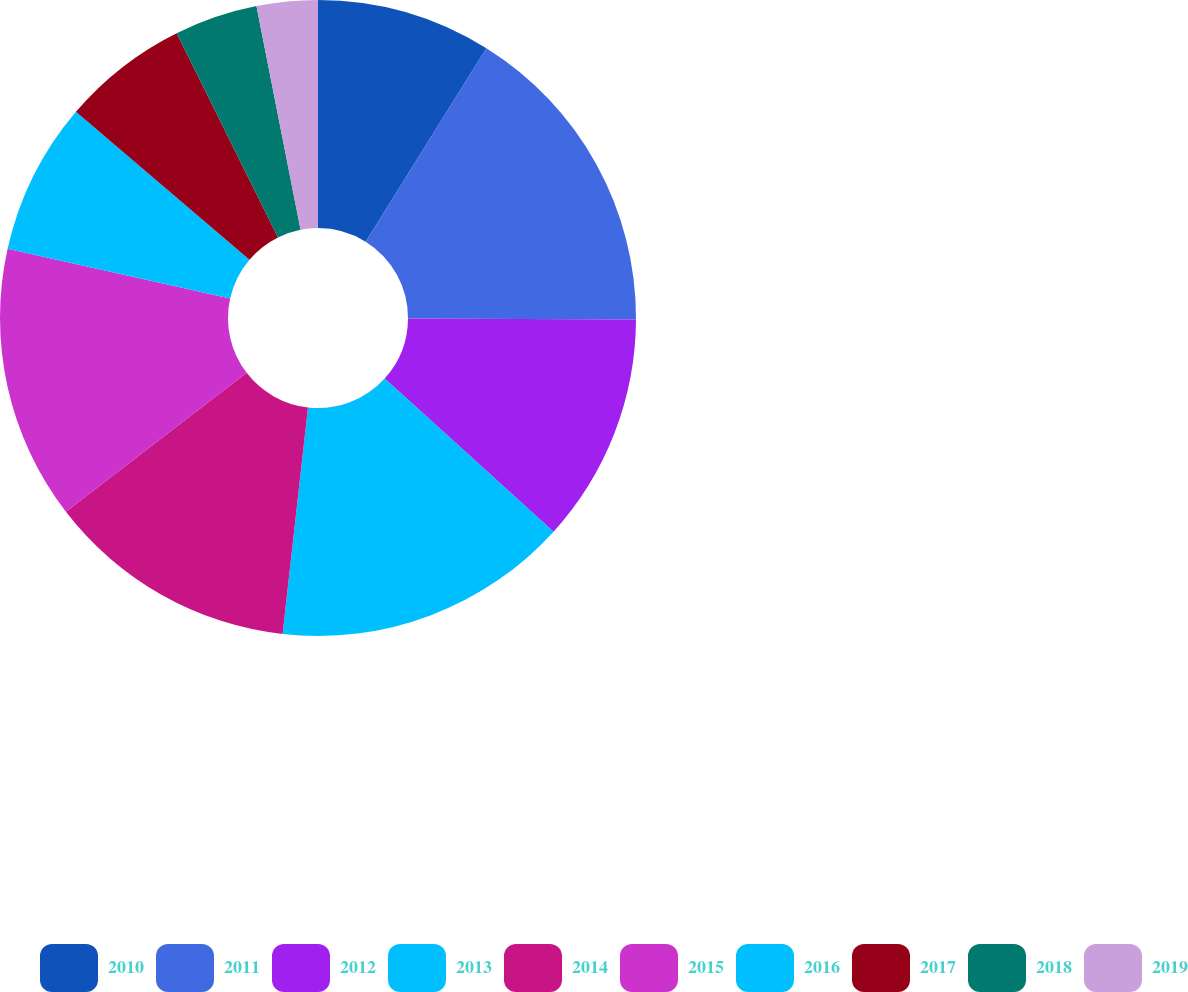Convert chart to OTSL. <chart><loc_0><loc_0><loc_500><loc_500><pie_chart><fcel>2010<fcel>2011<fcel>2012<fcel>2013<fcel>2014<fcel>2015<fcel>2016<fcel>2017<fcel>2018<fcel>2019<nl><fcel>8.88%<fcel>16.19%<fcel>11.65%<fcel>15.05%<fcel>12.79%<fcel>13.92%<fcel>7.74%<fcel>6.44%<fcel>4.23%<fcel>3.1%<nl></chart> 